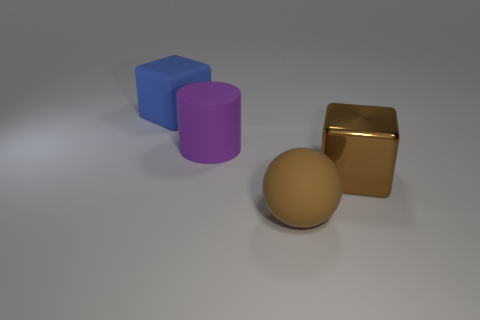Add 4 big green rubber balls. How many objects exist? 8 Subtract all blue cubes. How many cubes are left? 1 Subtract all cylinders. How many objects are left? 3 Subtract 2 blocks. How many blocks are left? 0 Subtract all large blue cubes. Subtract all brown metallic things. How many objects are left? 2 Add 3 big brown rubber spheres. How many big brown rubber spheres are left? 4 Add 1 big rubber cylinders. How many big rubber cylinders exist? 2 Subtract 0 red cubes. How many objects are left? 4 Subtract all yellow balls. Subtract all gray cylinders. How many balls are left? 1 